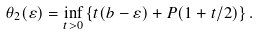Convert formula to latex. <formula><loc_0><loc_0><loc_500><loc_500>\theta _ { 2 } ( \varepsilon ) = \inf _ { t > 0 } \left \{ t ( b - \varepsilon ) + P ( 1 + t / 2 ) \right \} .</formula> 